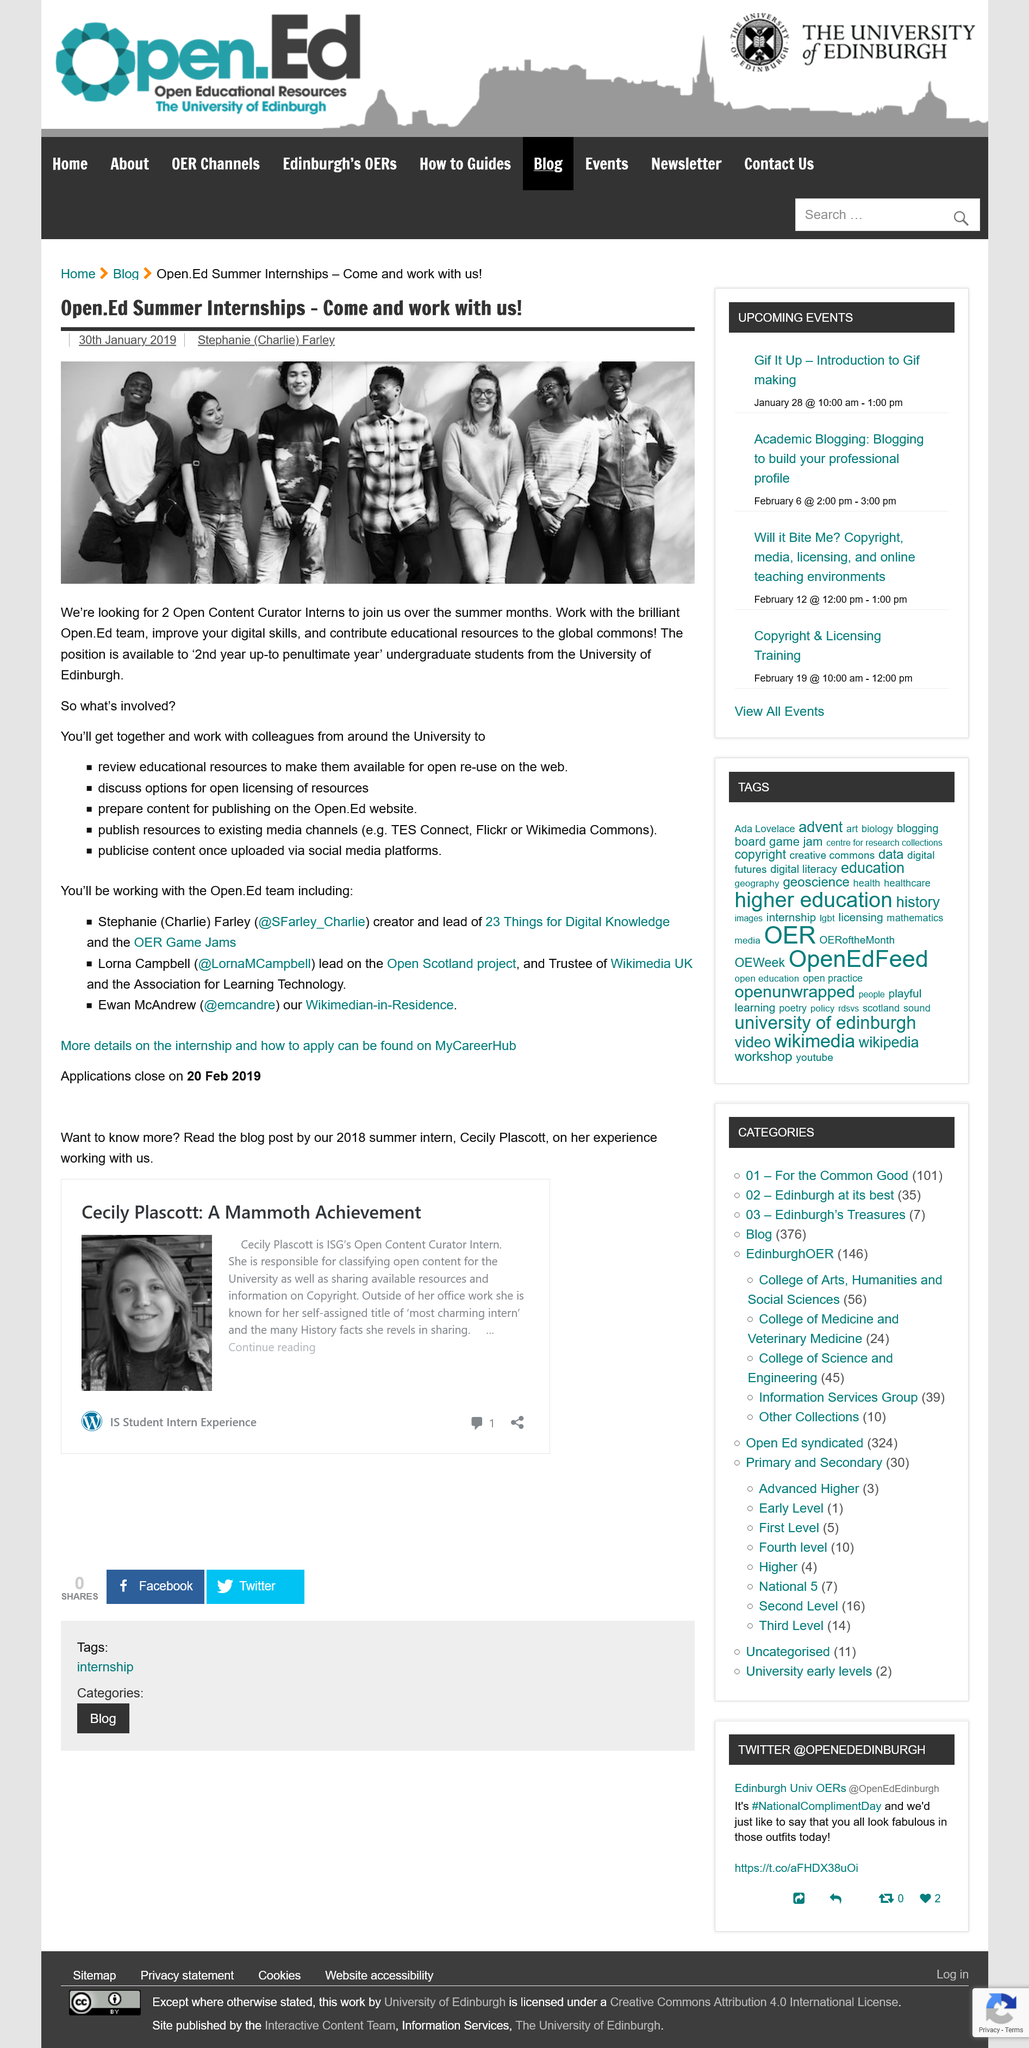Highlight a few significant elements in this photo. I, Stephanie Farley, am the creator and lead of 23 Things for Digital Knowledge. The ISG's Open Curator Intern is Cecily Plascott. The closing date for applications for the internship is the 20th February 2019. Open.Ed is currently seeking two interns to fill available positions. Open Content Curator Interns at Open.Ed review and evaluate educational resources, select appropriate content, and ensure its open re-use by reviewing options for open licensing and preparing it for publishing on the Open.Ed website, as well as promoting the content through social media platforms. 